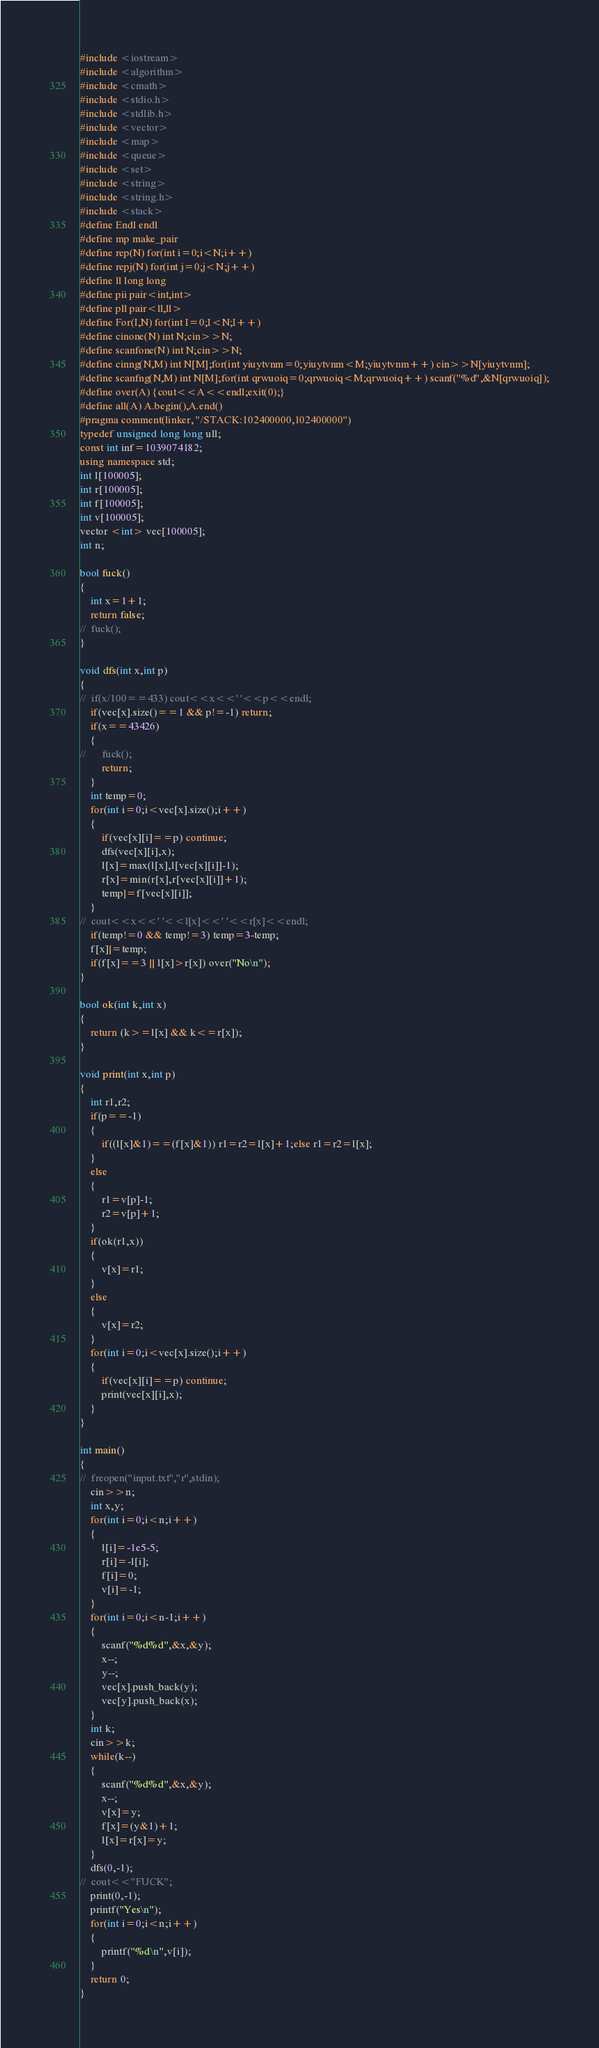Convert code to text. <code><loc_0><loc_0><loc_500><loc_500><_C++_>#include <iostream>
#include <algorithm>
#include <cmath>
#include <stdio.h>
#include <stdlib.h>
#include <vector>
#include <map>
#include <queue>
#include <set>
#include <string>
#include <string.h>
#include <stack>
#define Endl endl
#define mp make_pair
#define rep(N) for(int i=0;i<N;i++)
#define repj(N) for(int j=0;j<N;j++)
#define ll long long 
#define pii pair<int,int>
#define pll pair<ll,ll>
#define For(I,N) for(int I=0;I<N;I++)
#define cinone(N) int N;cin>>N;
#define scanfone(N) int N;cin>>N;
#define cinng(N,M) int N[M];for(int yiuytvnm=0;yiuytvnm<M;yiuytvnm++) cin>>N[yiuytvnm];
#define scanfng(N,M) int N[M];for(int qrwuoiq=0;qrwuoiq<M;qrwuoiq++) scanf("%d",&N[qrwuoiq]);
#define over(A) {cout<<A<<endl;exit(0);}
#define all(A) A.begin(),A.end()
#pragma comment(linker, "/STACK:102400000,102400000")
typedef unsigned long long ull;
const int inf=1039074182;
using namespace std;
int l[100005];
int r[100005];
int f[100005];
int v[100005];
vector <int> vec[100005];
int n;

bool fuck()
{
	int x=1+1;
	return false;
//	fuck();
}

void dfs(int x,int p)
{
//	if(x/100==433) cout<<x<<' '<<p<<endl;
	if(vec[x].size()==1 && p!=-1) return;
	if(x==43426)
	{
//		fuck();
		return;
	}
	int temp=0;
	for(int i=0;i<vec[x].size();i++)
	{
		if(vec[x][i]==p) continue;
		dfs(vec[x][i],x);
		l[x]=max(l[x],l[vec[x][i]]-1);
		r[x]=min(r[x],r[vec[x][i]]+1);
		temp|=f[vec[x][i]];
	}
//	cout<<x<<' '<<l[x]<<' '<<r[x]<<endl;
	if(temp!=0 && temp!=3) temp=3-temp;
	f[x]|=temp;
	if(f[x]==3 || l[x]>r[x]) over("No\n");
}

bool ok(int k,int x)
{
	return (k>=l[x] && k<=r[x]);
}

void print(int x,int p)
{
	int r1,r2;
	if(p==-1)
	{
		if((l[x]&1)==(f[x]&1)) r1=r2=l[x]+1;else r1=r2=l[x];
	}
	else
	{
		r1=v[p]-1;
		r2=v[p]+1;
	}
	if(ok(r1,x))
	{
		v[x]=r1;
	}
	else
	{
		v[x]=r2;
	}
	for(int i=0;i<vec[x].size();i++)
	{
		if(vec[x][i]==p) continue;
		print(vec[x][i],x);
	}
}

int main()
{	
//	freopen("input.txt","r",stdin);
	cin>>n;
	int x,y;
	for(int i=0;i<n;i++)
	{
		l[i]=-1e5-5;
		r[i]=-l[i];
		f[i]=0;
		v[i]=-1;
	}
	for(int i=0;i<n-1;i++)
	{
		scanf("%d%d",&x,&y);
		x--;
		y--;
		vec[x].push_back(y);
		vec[y].push_back(x);
	}
	int k;
	cin>>k;
	while(k--)
	{
		scanf("%d%d",&x,&y);
		x--;
		v[x]=y;
		f[x]=(y&1)+1;
		l[x]=r[x]=y;
	}
	dfs(0,-1);
//	cout<<"FUCK";
	print(0,-1);
	printf("Yes\n");
	for(int i=0;i<n;i++)
	{
		printf("%d\n",v[i]);
	}
	return 0;
}</code> 